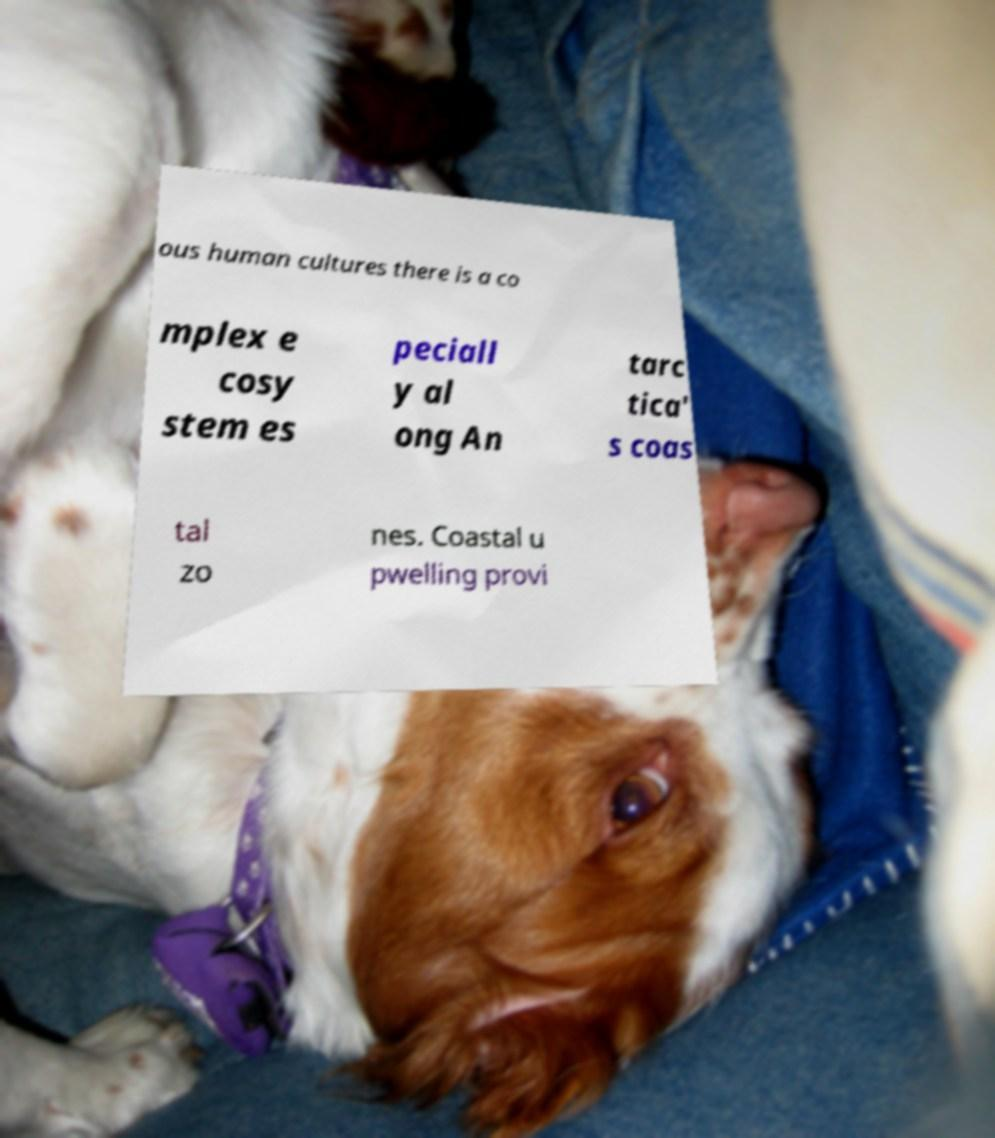Can you accurately transcribe the text from the provided image for me? ous human cultures there is a co mplex e cosy stem es peciall y al ong An tarc tica' s coas tal zo nes. Coastal u pwelling provi 